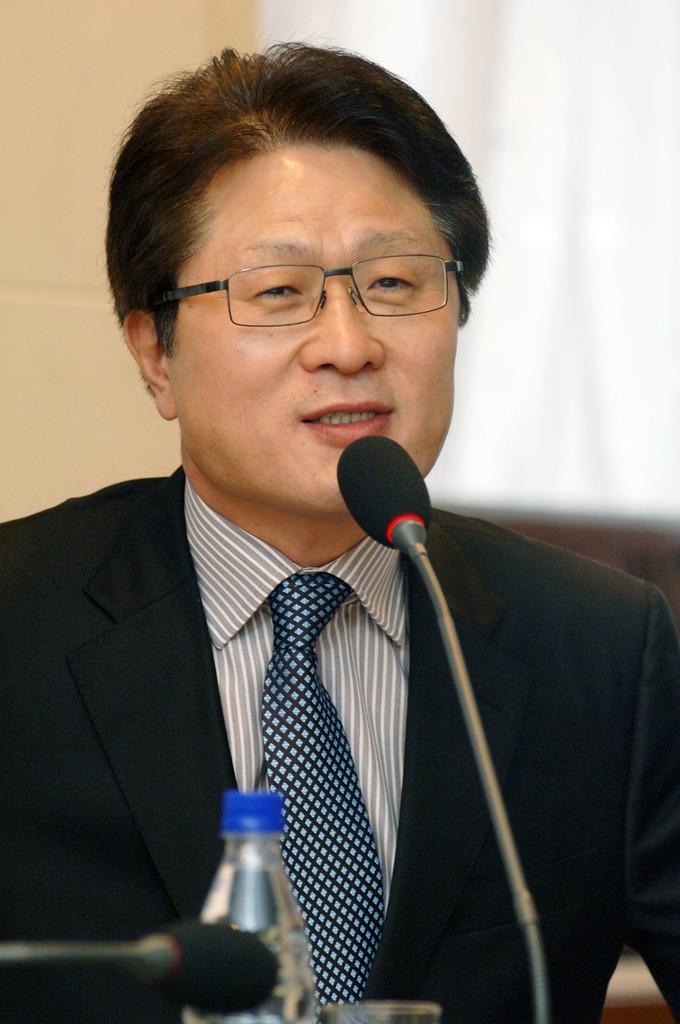Can you describe this image briefly? In this image we can see a person. He is wearing a suit and he is speaking on a microphone. Here we can see a water bottle. 